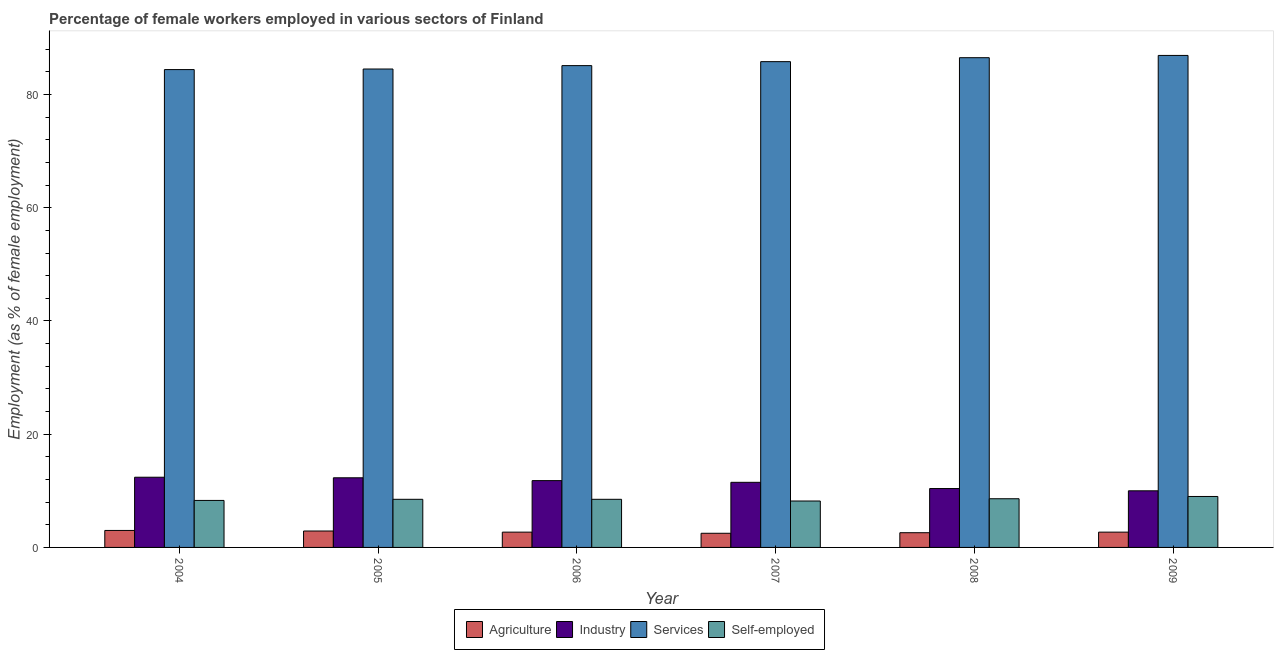How many different coloured bars are there?
Your response must be concise. 4. How many groups of bars are there?
Give a very brief answer. 6. Are the number of bars per tick equal to the number of legend labels?
Keep it short and to the point. Yes. Are the number of bars on each tick of the X-axis equal?
Provide a short and direct response. Yes. How many bars are there on the 5th tick from the left?
Give a very brief answer. 4. How many bars are there on the 3rd tick from the right?
Your response must be concise. 4. In how many cases, is the number of bars for a given year not equal to the number of legend labels?
Provide a short and direct response. 0. What is the percentage of female workers in industry in 2006?
Keep it short and to the point. 11.8. Across all years, what is the maximum percentage of female workers in industry?
Provide a short and direct response. 12.4. In which year was the percentage of female workers in agriculture maximum?
Provide a succinct answer. 2004. In which year was the percentage of female workers in services minimum?
Give a very brief answer. 2004. What is the total percentage of female workers in services in the graph?
Offer a terse response. 513.2. What is the difference between the percentage of female workers in industry in 2004 and that in 2005?
Offer a terse response. 0.1. What is the difference between the percentage of self employed female workers in 2004 and the percentage of female workers in services in 2006?
Ensure brevity in your answer.  -0.2. What is the average percentage of female workers in services per year?
Your answer should be very brief. 85.53. In how many years, is the percentage of female workers in agriculture greater than 76 %?
Your answer should be very brief. 0. What is the ratio of the percentage of female workers in industry in 2004 to that in 2006?
Offer a terse response. 1.05. What is the difference between the highest and the second highest percentage of self employed female workers?
Keep it short and to the point. 0.4. What is the difference between the highest and the lowest percentage of self employed female workers?
Give a very brief answer. 0.8. In how many years, is the percentage of self employed female workers greater than the average percentage of self employed female workers taken over all years?
Provide a short and direct response. 2. Is it the case that in every year, the sum of the percentage of female workers in industry and percentage of female workers in agriculture is greater than the sum of percentage of female workers in services and percentage of self employed female workers?
Give a very brief answer. Yes. What does the 4th bar from the left in 2009 represents?
Offer a terse response. Self-employed. What does the 2nd bar from the right in 2007 represents?
Make the answer very short. Services. Is it the case that in every year, the sum of the percentage of female workers in agriculture and percentage of female workers in industry is greater than the percentage of female workers in services?
Provide a succinct answer. No. Are all the bars in the graph horizontal?
Keep it short and to the point. No. How many years are there in the graph?
Your response must be concise. 6. What is the difference between two consecutive major ticks on the Y-axis?
Keep it short and to the point. 20. How many legend labels are there?
Your answer should be compact. 4. What is the title of the graph?
Ensure brevity in your answer.  Percentage of female workers employed in various sectors of Finland. Does "Miscellaneous expenses" appear as one of the legend labels in the graph?
Offer a very short reply. No. What is the label or title of the X-axis?
Offer a terse response. Year. What is the label or title of the Y-axis?
Your answer should be very brief. Employment (as % of female employment). What is the Employment (as % of female employment) in Industry in 2004?
Provide a short and direct response. 12.4. What is the Employment (as % of female employment) of Services in 2004?
Provide a short and direct response. 84.4. What is the Employment (as % of female employment) in Self-employed in 2004?
Offer a very short reply. 8.3. What is the Employment (as % of female employment) in Agriculture in 2005?
Provide a succinct answer. 2.9. What is the Employment (as % of female employment) in Industry in 2005?
Your answer should be very brief. 12.3. What is the Employment (as % of female employment) in Services in 2005?
Give a very brief answer. 84.5. What is the Employment (as % of female employment) in Agriculture in 2006?
Give a very brief answer. 2.7. What is the Employment (as % of female employment) in Industry in 2006?
Your answer should be very brief. 11.8. What is the Employment (as % of female employment) of Services in 2006?
Your answer should be very brief. 85.1. What is the Employment (as % of female employment) of Agriculture in 2007?
Provide a short and direct response. 2.5. What is the Employment (as % of female employment) in Industry in 2007?
Give a very brief answer. 11.5. What is the Employment (as % of female employment) in Services in 2007?
Make the answer very short. 85.8. What is the Employment (as % of female employment) in Self-employed in 2007?
Offer a very short reply. 8.2. What is the Employment (as % of female employment) of Agriculture in 2008?
Keep it short and to the point. 2.6. What is the Employment (as % of female employment) of Industry in 2008?
Your answer should be compact. 10.4. What is the Employment (as % of female employment) of Services in 2008?
Your answer should be compact. 86.5. What is the Employment (as % of female employment) in Self-employed in 2008?
Your response must be concise. 8.6. What is the Employment (as % of female employment) of Agriculture in 2009?
Make the answer very short. 2.7. What is the Employment (as % of female employment) in Industry in 2009?
Keep it short and to the point. 10. What is the Employment (as % of female employment) in Services in 2009?
Give a very brief answer. 86.9. What is the Employment (as % of female employment) of Self-employed in 2009?
Offer a terse response. 9. Across all years, what is the maximum Employment (as % of female employment) in Industry?
Ensure brevity in your answer.  12.4. Across all years, what is the maximum Employment (as % of female employment) of Services?
Provide a short and direct response. 86.9. Across all years, what is the maximum Employment (as % of female employment) of Self-employed?
Offer a very short reply. 9. Across all years, what is the minimum Employment (as % of female employment) of Industry?
Your answer should be compact. 10. Across all years, what is the minimum Employment (as % of female employment) in Services?
Your answer should be compact. 84.4. Across all years, what is the minimum Employment (as % of female employment) in Self-employed?
Your answer should be very brief. 8.2. What is the total Employment (as % of female employment) of Agriculture in the graph?
Give a very brief answer. 16.4. What is the total Employment (as % of female employment) in Industry in the graph?
Keep it short and to the point. 68.4. What is the total Employment (as % of female employment) of Services in the graph?
Make the answer very short. 513.2. What is the total Employment (as % of female employment) in Self-employed in the graph?
Give a very brief answer. 51.1. What is the difference between the Employment (as % of female employment) of Industry in 2004 and that in 2005?
Your response must be concise. 0.1. What is the difference between the Employment (as % of female employment) in Self-employed in 2004 and that in 2005?
Offer a terse response. -0.2. What is the difference between the Employment (as % of female employment) of Agriculture in 2004 and that in 2006?
Your answer should be very brief. 0.3. What is the difference between the Employment (as % of female employment) in Industry in 2004 and that in 2006?
Make the answer very short. 0.6. What is the difference between the Employment (as % of female employment) of Services in 2004 and that in 2006?
Your answer should be compact. -0.7. What is the difference between the Employment (as % of female employment) of Agriculture in 2004 and that in 2007?
Your answer should be compact. 0.5. What is the difference between the Employment (as % of female employment) of Industry in 2004 and that in 2007?
Provide a short and direct response. 0.9. What is the difference between the Employment (as % of female employment) in Services in 2004 and that in 2007?
Provide a succinct answer. -1.4. What is the difference between the Employment (as % of female employment) in Agriculture in 2004 and that in 2008?
Ensure brevity in your answer.  0.4. What is the difference between the Employment (as % of female employment) in Self-employed in 2004 and that in 2008?
Keep it short and to the point. -0.3. What is the difference between the Employment (as % of female employment) in Industry in 2004 and that in 2009?
Ensure brevity in your answer.  2.4. What is the difference between the Employment (as % of female employment) of Services in 2004 and that in 2009?
Make the answer very short. -2.5. What is the difference between the Employment (as % of female employment) of Self-employed in 2004 and that in 2009?
Keep it short and to the point. -0.7. What is the difference between the Employment (as % of female employment) in Industry in 2005 and that in 2006?
Make the answer very short. 0.5. What is the difference between the Employment (as % of female employment) of Industry in 2005 and that in 2007?
Keep it short and to the point. 0.8. What is the difference between the Employment (as % of female employment) in Services in 2005 and that in 2007?
Make the answer very short. -1.3. What is the difference between the Employment (as % of female employment) in Self-employed in 2005 and that in 2007?
Ensure brevity in your answer.  0.3. What is the difference between the Employment (as % of female employment) of Services in 2005 and that in 2008?
Provide a succinct answer. -2. What is the difference between the Employment (as % of female employment) in Industry in 2005 and that in 2009?
Offer a very short reply. 2.3. What is the difference between the Employment (as % of female employment) of Agriculture in 2006 and that in 2007?
Offer a terse response. 0.2. What is the difference between the Employment (as % of female employment) in Self-employed in 2006 and that in 2007?
Your response must be concise. 0.3. What is the difference between the Employment (as % of female employment) in Agriculture in 2006 and that in 2008?
Offer a very short reply. 0.1. What is the difference between the Employment (as % of female employment) in Industry in 2006 and that in 2008?
Provide a short and direct response. 1.4. What is the difference between the Employment (as % of female employment) of Services in 2006 and that in 2008?
Give a very brief answer. -1.4. What is the difference between the Employment (as % of female employment) in Self-employed in 2006 and that in 2008?
Your answer should be very brief. -0.1. What is the difference between the Employment (as % of female employment) of Agriculture in 2006 and that in 2009?
Give a very brief answer. 0. What is the difference between the Employment (as % of female employment) of Industry in 2006 and that in 2009?
Your answer should be compact. 1.8. What is the difference between the Employment (as % of female employment) in Self-employed in 2006 and that in 2009?
Keep it short and to the point. -0.5. What is the difference between the Employment (as % of female employment) of Industry in 2007 and that in 2008?
Provide a succinct answer. 1.1. What is the difference between the Employment (as % of female employment) in Services in 2007 and that in 2008?
Keep it short and to the point. -0.7. What is the difference between the Employment (as % of female employment) in Industry in 2007 and that in 2009?
Your answer should be very brief. 1.5. What is the difference between the Employment (as % of female employment) of Services in 2007 and that in 2009?
Your answer should be compact. -1.1. What is the difference between the Employment (as % of female employment) in Industry in 2008 and that in 2009?
Your response must be concise. 0.4. What is the difference between the Employment (as % of female employment) of Self-employed in 2008 and that in 2009?
Your response must be concise. -0.4. What is the difference between the Employment (as % of female employment) of Agriculture in 2004 and the Employment (as % of female employment) of Services in 2005?
Give a very brief answer. -81.5. What is the difference between the Employment (as % of female employment) of Agriculture in 2004 and the Employment (as % of female employment) of Self-employed in 2005?
Keep it short and to the point. -5.5. What is the difference between the Employment (as % of female employment) of Industry in 2004 and the Employment (as % of female employment) of Services in 2005?
Provide a succinct answer. -72.1. What is the difference between the Employment (as % of female employment) in Industry in 2004 and the Employment (as % of female employment) in Self-employed in 2005?
Your response must be concise. 3.9. What is the difference between the Employment (as % of female employment) of Services in 2004 and the Employment (as % of female employment) of Self-employed in 2005?
Ensure brevity in your answer.  75.9. What is the difference between the Employment (as % of female employment) of Agriculture in 2004 and the Employment (as % of female employment) of Services in 2006?
Offer a very short reply. -82.1. What is the difference between the Employment (as % of female employment) of Industry in 2004 and the Employment (as % of female employment) of Services in 2006?
Your response must be concise. -72.7. What is the difference between the Employment (as % of female employment) of Industry in 2004 and the Employment (as % of female employment) of Self-employed in 2006?
Your response must be concise. 3.9. What is the difference between the Employment (as % of female employment) of Services in 2004 and the Employment (as % of female employment) of Self-employed in 2006?
Make the answer very short. 75.9. What is the difference between the Employment (as % of female employment) of Agriculture in 2004 and the Employment (as % of female employment) of Industry in 2007?
Make the answer very short. -8.5. What is the difference between the Employment (as % of female employment) of Agriculture in 2004 and the Employment (as % of female employment) of Services in 2007?
Your answer should be very brief. -82.8. What is the difference between the Employment (as % of female employment) of Industry in 2004 and the Employment (as % of female employment) of Services in 2007?
Offer a terse response. -73.4. What is the difference between the Employment (as % of female employment) in Industry in 2004 and the Employment (as % of female employment) in Self-employed in 2007?
Provide a succinct answer. 4.2. What is the difference between the Employment (as % of female employment) in Services in 2004 and the Employment (as % of female employment) in Self-employed in 2007?
Your response must be concise. 76.2. What is the difference between the Employment (as % of female employment) of Agriculture in 2004 and the Employment (as % of female employment) of Industry in 2008?
Provide a succinct answer. -7.4. What is the difference between the Employment (as % of female employment) of Agriculture in 2004 and the Employment (as % of female employment) of Services in 2008?
Make the answer very short. -83.5. What is the difference between the Employment (as % of female employment) of Agriculture in 2004 and the Employment (as % of female employment) of Self-employed in 2008?
Ensure brevity in your answer.  -5.6. What is the difference between the Employment (as % of female employment) of Industry in 2004 and the Employment (as % of female employment) of Services in 2008?
Make the answer very short. -74.1. What is the difference between the Employment (as % of female employment) in Services in 2004 and the Employment (as % of female employment) in Self-employed in 2008?
Make the answer very short. 75.8. What is the difference between the Employment (as % of female employment) in Agriculture in 2004 and the Employment (as % of female employment) in Industry in 2009?
Your answer should be very brief. -7. What is the difference between the Employment (as % of female employment) of Agriculture in 2004 and the Employment (as % of female employment) of Services in 2009?
Ensure brevity in your answer.  -83.9. What is the difference between the Employment (as % of female employment) in Agriculture in 2004 and the Employment (as % of female employment) in Self-employed in 2009?
Ensure brevity in your answer.  -6. What is the difference between the Employment (as % of female employment) of Industry in 2004 and the Employment (as % of female employment) of Services in 2009?
Ensure brevity in your answer.  -74.5. What is the difference between the Employment (as % of female employment) of Services in 2004 and the Employment (as % of female employment) of Self-employed in 2009?
Your answer should be compact. 75.4. What is the difference between the Employment (as % of female employment) in Agriculture in 2005 and the Employment (as % of female employment) in Services in 2006?
Ensure brevity in your answer.  -82.2. What is the difference between the Employment (as % of female employment) in Agriculture in 2005 and the Employment (as % of female employment) in Self-employed in 2006?
Give a very brief answer. -5.6. What is the difference between the Employment (as % of female employment) in Industry in 2005 and the Employment (as % of female employment) in Services in 2006?
Your answer should be very brief. -72.8. What is the difference between the Employment (as % of female employment) in Industry in 2005 and the Employment (as % of female employment) in Self-employed in 2006?
Make the answer very short. 3.8. What is the difference between the Employment (as % of female employment) in Services in 2005 and the Employment (as % of female employment) in Self-employed in 2006?
Your response must be concise. 76. What is the difference between the Employment (as % of female employment) of Agriculture in 2005 and the Employment (as % of female employment) of Services in 2007?
Provide a succinct answer. -82.9. What is the difference between the Employment (as % of female employment) of Agriculture in 2005 and the Employment (as % of female employment) of Self-employed in 2007?
Provide a short and direct response. -5.3. What is the difference between the Employment (as % of female employment) of Industry in 2005 and the Employment (as % of female employment) of Services in 2007?
Offer a very short reply. -73.5. What is the difference between the Employment (as % of female employment) of Industry in 2005 and the Employment (as % of female employment) of Self-employed in 2007?
Give a very brief answer. 4.1. What is the difference between the Employment (as % of female employment) in Services in 2005 and the Employment (as % of female employment) in Self-employed in 2007?
Provide a short and direct response. 76.3. What is the difference between the Employment (as % of female employment) of Agriculture in 2005 and the Employment (as % of female employment) of Industry in 2008?
Offer a very short reply. -7.5. What is the difference between the Employment (as % of female employment) in Agriculture in 2005 and the Employment (as % of female employment) in Services in 2008?
Your answer should be very brief. -83.6. What is the difference between the Employment (as % of female employment) of Industry in 2005 and the Employment (as % of female employment) of Services in 2008?
Make the answer very short. -74.2. What is the difference between the Employment (as % of female employment) of Industry in 2005 and the Employment (as % of female employment) of Self-employed in 2008?
Your answer should be very brief. 3.7. What is the difference between the Employment (as % of female employment) of Services in 2005 and the Employment (as % of female employment) of Self-employed in 2008?
Ensure brevity in your answer.  75.9. What is the difference between the Employment (as % of female employment) of Agriculture in 2005 and the Employment (as % of female employment) of Services in 2009?
Ensure brevity in your answer.  -84. What is the difference between the Employment (as % of female employment) of Agriculture in 2005 and the Employment (as % of female employment) of Self-employed in 2009?
Provide a succinct answer. -6.1. What is the difference between the Employment (as % of female employment) of Industry in 2005 and the Employment (as % of female employment) of Services in 2009?
Offer a terse response. -74.6. What is the difference between the Employment (as % of female employment) in Industry in 2005 and the Employment (as % of female employment) in Self-employed in 2009?
Your answer should be compact. 3.3. What is the difference between the Employment (as % of female employment) of Services in 2005 and the Employment (as % of female employment) of Self-employed in 2009?
Ensure brevity in your answer.  75.5. What is the difference between the Employment (as % of female employment) of Agriculture in 2006 and the Employment (as % of female employment) of Industry in 2007?
Keep it short and to the point. -8.8. What is the difference between the Employment (as % of female employment) of Agriculture in 2006 and the Employment (as % of female employment) of Services in 2007?
Make the answer very short. -83.1. What is the difference between the Employment (as % of female employment) in Industry in 2006 and the Employment (as % of female employment) in Services in 2007?
Keep it short and to the point. -74. What is the difference between the Employment (as % of female employment) in Services in 2006 and the Employment (as % of female employment) in Self-employed in 2007?
Keep it short and to the point. 76.9. What is the difference between the Employment (as % of female employment) of Agriculture in 2006 and the Employment (as % of female employment) of Services in 2008?
Your answer should be compact. -83.8. What is the difference between the Employment (as % of female employment) of Agriculture in 2006 and the Employment (as % of female employment) of Self-employed in 2008?
Give a very brief answer. -5.9. What is the difference between the Employment (as % of female employment) in Industry in 2006 and the Employment (as % of female employment) in Services in 2008?
Keep it short and to the point. -74.7. What is the difference between the Employment (as % of female employment) of Industry in 2006 and the Employment (as % of female employment) of Self-employed in 2008?
Give a very brief answer. 3.2. What is the difference between the Employment (as % of female employment) of Services in 2006 and the Employment (as % of female employment) of Self-employed in 2008?
Provide a short and direct response. 76.5. What is the difference between the Employment (as % of female employment) in Agriculture in 2006 and the Employment (as % of female employment) in Services in 2009?
Make the answer very short. -84.2. What is the difference between the Employment (as % of female employment) of Industry in 2006 and the Employment (as % of female employment) of Services in 2009?
Ensure brevity in your answer.  -75.1. What is the difference between the Employment (as % of female employment) in Services in 2006 and the Employment (as % of female employment) in Self-employed in 2009?
Give a very brief answer. 76.1. What is the difference between the Employment (as % of female employment) of Agriculture in 2007 and the Employment (as % of female employment) of Services in 2008?
Make the answer very short. -84. What is the difference between the Employment (as % of female employment) in Industry in 2007 and the Employment (as % of female employment) in Services in 2008?
Provide a succinct answer. -75. What is the difference between the Employment (as % of female employment) in Industry in 2007 and the Employment (as % of female employment) in Self-employed in 2008?
Provide a short and direct response. 2.9. What is the difference between the Employment (as % of female employment) in Services in 2007 and the Employment (as % of female employment) in Self-employed in 2008?
Your response must be concise. 77.2. What is the difference between the Employment (as % of female employment) of Agriculture in 2007 and the Employment (as % of female employment) of Industry in 2009?
Your answer should be very brief. -7.5. What is the difference between the Employment (as % of female employment) of Agriculture in 2007 and the Employment (as % of female employment) of Services in 2009?
Provide a short and direct response. -84.4. What is the difference between the Employment (as % of female employment) of Agriculture in 2007 and the Employment (as % of female employment) of Self-employed in 2009?
Offer a very short reply. -6.5. What is the difference between the Employment (as % of female employment) of Industry in 2007 and the Employment (as % of female employment) of Services in 2009?
Keep it short and to the point. -75.4. What is the difference between the Employment (as % of female employment) in Industry in 2007 and the Employment (as % of female employment) in Self-employed in 2009?
Offer a very short reply. 2.5. What is the difference between the Employment (as % of female employment) in Services in 2007 and the Employment (as % of female employment) in Self-employed in 2009?
Provide a short and direct response. 76.8. What is the difference between the Employment (as % of female employment) in Agriculture in 2008 and the Employment (as % of female employment) in Industry in 2009?
Make the answer very short. -7.4. What is the difference between the Employment (as % of female employment) of Agriculture in 2008 and the Employment (as % of female employment) of Services in 2009?
Offer a very short reply. -84.3. What is the difference between the Employment (as % of female employment) of Industry in 2008 and the Employment (as % of female employment) of Services in 2009?
Keep it short and to the point. -76.5. What is the difference between the Employment (as % of female employment) of Industry in 2008 and the Employment (as % of female employment) of Self-employed in 2009?
Offer a terse response. 1.4. What is the difference between the Employment (as % of female employment) of Services in 2008 and the Employment (as % of female employment) of Self-employed in 2009?
Ensure brevity in your answer.  77.5. What is the average Employment (as % of female employment) in Agriculture per year?
Your answer should be very brief. 2.73. What is the average Employment (as % of female employment) of Industry per year?
Provide a short and direct response. 11.4. What is the average Employment (as % of female employment) of Services per year?
Provide a succinct answer. 85.53. What is the average Employment (as % of female employment) of Self-employed per year?
Keep it short and to the point. 8.52. In the year 2004, what is the difference between the Employment (as % of female employment) in Agriculture and Employment (as % of female employment) in Industry?
Offer a terse response. -9.4. In the year 2004, what is the difference between the Employment (as % of female employment) in Agriculture and Employment (as % of female employment) in Services?
Your response must be concise. -81.4. In the year 2004, what is the difference between the Employment (as % of female employment) of Industry and Employment (as % of female employment) of Services?
Give a very brief answer. -72. In the year 2004, what is the difference between the Employment (as % of female employment) of Services and Employment (as % of female employment) of Self-employed?
Provide a short and direct response. 76.1. In the year 2005, what is the difference between the Employment (as % of female employment) in Agriculture and Employment (as % of female employment) in Services?
Provide a short and direct response. -81.6. In the year 2005, what is the difference between the Employment (as % of female employment) of Industry and Employment (as % of female employment) of Services?
Offer a very short reply. -72.2. In the year 2005, what is the difference between the Employment (as % of female employment) in Industry and Employment (as % of female employment) in Self-employed?
Offer a terse response. 3.8. In the year 2006, what is the difference between the Employment (as % of female employment) in Agriculture and Employment (as % of female employment) in Services?
Offer a terse response. -82.4. In the year 2006, what is the difference between the Employment (as % of female employment) in Agriculture and Employment (as % of female employment) in Self-employed?
Your answer should be compact. -5.8. In the year 2006, what is the difference between the Employment (as % of female employment) of Industry and Employment (as % of female employment) of Services?
Your answer should be compact. -73.3. In the year 2006, what is the difference between the Employment (as % of female employment) in Industry and Employment (as % of female employment) in Self-employed?
Your answer should be compact. 3.3. In the year 2006, what is the difference between the Employment (as % of female employment) of Services and Employment (as % of female employment) of Self-employed?
Offer a very short reply. 76.6. In the year 2007, what is the difference between the Employment (as % of female employment) of Agriculture and Employment (as % of female employment) of Industry?
Offer a terse response. -9. In the year 2007, what is the difference between the Employment (as % of female employment) of Agriculture and Employment (as % of female employment) of Services?
Your answer should be compact. -83.3. In the year 2007, what is the difference between the Employment (as % of female employment) in Agriculture and Employment (as % of female employment) in Self-employed?
Provide a succinct answer. -5.7. In the year 2007, what is the difference between the Employment (as % of female employment) of Industry and Employment (as % of female employment) of Services?
Offer a terse response. -74.3. In the year 2007, what is the difference between the Employment (as % of female employment) in Services and Employment (as % of female employment) in Self-employed?
Your answer should be very brief. 77.6. In the year 2008, what is the difference between the Employment (as % of female employment) in Agriculture and Employment (as % of female employment) in Services?
Ensure brevity in your answer.  -83.9. In the year 2008, what is the difference between the Employment (as % of female employment) of Industry and Employment (as % of female employment) of Services?
Offer a terse response. -76.1. In the year 2008, what is the difference between the Employment (as % of female employment) of Industry and Employment (as % of female employment) of Self-employed?
Ensure brevity in your answer.  1.8. In the year 2008, what is the difference between the Employment (as % of female employment) in Services and Employment (as % of female employment) in Self-employed?
Your response must be concise. 77.9. In the year 2009, what is the difference between the Employment (as % of female employment) in Agriculture and Employment (as % of female employment) in Services?
Ensure brevity in your answer.  -84.2. In the year 2009, what is the difference between the Employment (as % of female employment) in Industry and Employment (as % of female employment) in Services?
Provide a short and direct response. -76.9. In the year 2009, what is the difference between the Employment (as % of female employment) of Services and Employment (as % of female employment) of Self-employed?
Give a very brief answer. 77.9. What is the ratio of the Employment (as % of female employment) of Agriculture in 2004 to that in 2005?
Your answer should be compact. 1.03. What is the ratio of the Employment (as % of female employment) of Self-employed in 2004 to that in 2005?
Your answer should be very brief. 0.98. What is the ratio of the Employment (as % of female employment) in Industry in 2004 to that in 2006?
Provide a succinct answer. 1.05. What is the ratio of the Employment (as % of female employment) of Services in 2004 to that in 2006?
Ensure brevity in your answer.  0.99. What is the ratio of the Employment (as % of female employment) of Self-employed in 2004 to that in 2006?
Make the answer very short. 0.98. What is the ratio of the Employment (as % of female employment) of Industry in 2004 to that in 2007?
Give a very brief answer. 1.08. What is the ratio of the Employment (as % of female employment) in Services in 2004 to that in 2007?
Offer a very short reply. 0.98. What is the ratio of the Employment (as % of female employment) of Self-employed in 2004 to that in 2007?
Your answer should be very brief. 1.01. What is the ratio of the Employment (as % of female employment) of Agriculture in 2004 to that in 2008?
Your answer should be compact. 1.15. What is the ratio of the Employment (as % of female employment) in Industry in 2004 to that in 2008?
Provide a short and direct response. 1.19. What is the ratio of the Employment (as % of female employment) of Services in 2004 to that in 2008?
Keep it short and to the point. 0.98. What is the ratio of the Employment (as % of female employment) of Self-employed in 2004 to that in 2008?
Make the answer very short. 0.97. What is the ratio of the Employment (as % of female employment) in Agriculture in 2004 to that in 2009?
Ensure brevity in your answer.  1.11. What is the ratio of the Employment (as % of female employment) of Industry in 2004 to that in 2009?
Your answer should be very brief. 1.24. What is the ratio of the Employment (as % of female employment) in Services in 2004 to that in 2009?
Your response must be concise. 0.97. What is the ratio of the Employment (as % of female employment) of Self-employed in 2004 to that in 2009?
Your answer should be compact. 0.92. What is the ratio of the Employment (as % of female employment) of Agriculture in 2005 to that in 2006?
Your response must be concise. 1.07. What is the ratio of the Employment (as % of female employment) in Industry in 2005 to that in 2006?
Give a very brief answer. 1.04. What is the ratio of the Employment (as % of female employment) of Services in 2005 to that in 2006?
Your answer should be compact. 0.99. What is the ratio of the Employment (as % of female employment) in Self-employed in 2005 to that in 2006?
Provide a short and direct response. 1. What is the ratio of the Employment (as % of female employment) of Agriculture in 2005 to that in 2007?
Offer a terse response. 1.16. What is the ratio of the Employment (as % of female employment) in Industry in 2005 to that in 2007?
Keep it short and to the point. 1.07. What is the ratio of the Employment (as % of female employment) in Services in 2005 to that in 2007?
Provide a succinct answer. 0.98. What is the ratio of the Employment (as % of female employment) of Self-employed in 2005 to that in 2007?
Your response must be concise. 1.04. What is the ratio of the Employment (as % of female employment) in Agriculture in 2005 to that in 2008?
Provide a short and direct response. 1.12. What is the ratio of the Employment (as % of female employment) in Industry in 2005 to that in 2008?
Make the answer very short. 1.18. What is the ratio of the Employment (as % of female employment) of Services in 2005 to that in 2008?
Keep it short and to the point. 0.98. What is the ratio of the Employment (as % of female employment) in Self-employed in 2005 to that in 2008?
Ensure brevity in your answer.  0.99. What is the ratio of the Employment (as % of female employment) in Agriculture in 2005 to that in 2009?
Offer a very short reply. 1.07. What is the ratio of the Employment (as % of female employment) in Industry in 2005 to that in 2009?
Make the answer very short. 1.23. What is the ratio of the Employment (as % of female employment) in Services in 2005 to that in 2009?
Offer a terse response. 0.97. What is the ratio of the Employment (as % of female employment) in Agriculture in 2006 to that in 2007?
Provide a short and direct response. 1.08. What is the ratio of the Employment (as % of female employment) of Industry in 2006 to that in 2007?
Your answer should be compact. 1.03. What is the ratio of the Employment (as % of female employment) in Services in 2006 to that in 2007?
Offer a very short reply. 0.99. What is the ratio of the Employment (as % of female employment) of Self-employed in 2006 to that in 2007?
Offer a very short reply. 1.04. What is the ratio of the Employment (as % of female employment) of Agriculture in 2006 to that in 2008?
Your response must be concise. 1.04. What is the ratio of the Employment (as % of female employment) in Industry in 2006 to that in 2008?
Your response must be concise. 1.13. What is the ratio of the Employment (as % of female employment) in Services in 2006 to that in 2008?
Give a very brief answer. 0.98. What is the ratio of the Employment (as % of female employment) of Self-employed in 2006 to that in 2008?
Your answer should be very brief. 0.99. What is the ratio of the Employment (as % of female employment) of Agriculture in 2006 to that in 2009?
Give a very brief answer. 1. What is the ratio of the Employment (as % of female employment) of Industry in 2006 to that in 2009?
Offer a very short reply. 1.18. What is the ratio of the Employment (as % of female employment) in Services in 2006 to that in 2009?
Provide a succinct answer. 0.98. What is the ratio of the Employment (as % of female employment) of Self-employed in 2006 to that in 2009?
Offer a very short reply. 0.94. What is the ratio of the Employment (as % of female employment) in Agriculture in 2007 to that in 2008?
Provide a short and direct response. 0.96. What is the ratio of the Employment (as % of female employment) in Industry in 2007 to that in 2008?
Give a very brief answer. 1.11. What is the ratio of the Employment (as % of female employment) of Services in 2007 to that in 2008?
Your answer should be very brief. 0.99. What is the ratio of the Employment (as % of female employment) of Self-employed in 2007 to that in 2008?
Your answer should be very brief. 0.95. What is the ratio of the Employment (as % of female employment) in Agriculture in 2007 to that in 2009?
Keep it short and to the point. 0.93. What is the ratio of the Employment (as % of female employment) of Industry in 2007 to that in 2009?
Ensure brevity in your answer.  1.15. What is the ratio of the Employment (as % of female employment) in Services in 2007 to that in 2009?
Your response must be concise. 0.99. What is the ratio of the Employment (as % of female employment) in Self-employed in 2007 to that in 2009?
Your answer should be compact. 0.91. What is the ratio of the Employment (as % of female employment) in Services in 2008 to that in 2009?
Make the answer very short. 1. What is the ratio of the Employment (as % of female employment) in Self-employed in 2008 to that in 2009?
Your answer should be compact. 0.96. What is the difference between the highest and the second highest Employment (as % of female employment) in Agriculture?
Provide a short and direct response. 0.1. What is the difference between the highest and the second highest Employment (as % of female employment) of Industry?
Keep it short and to the point. 0.1. What is the difference between the highest and the second highest Employment (as % of female employment) in Self-employed?
Provide a short and direct response. 0.4. What is the difference between the highest and the lowest Employment (as % of female employment) of Services?
Provide a succinct answer. 2.5. 